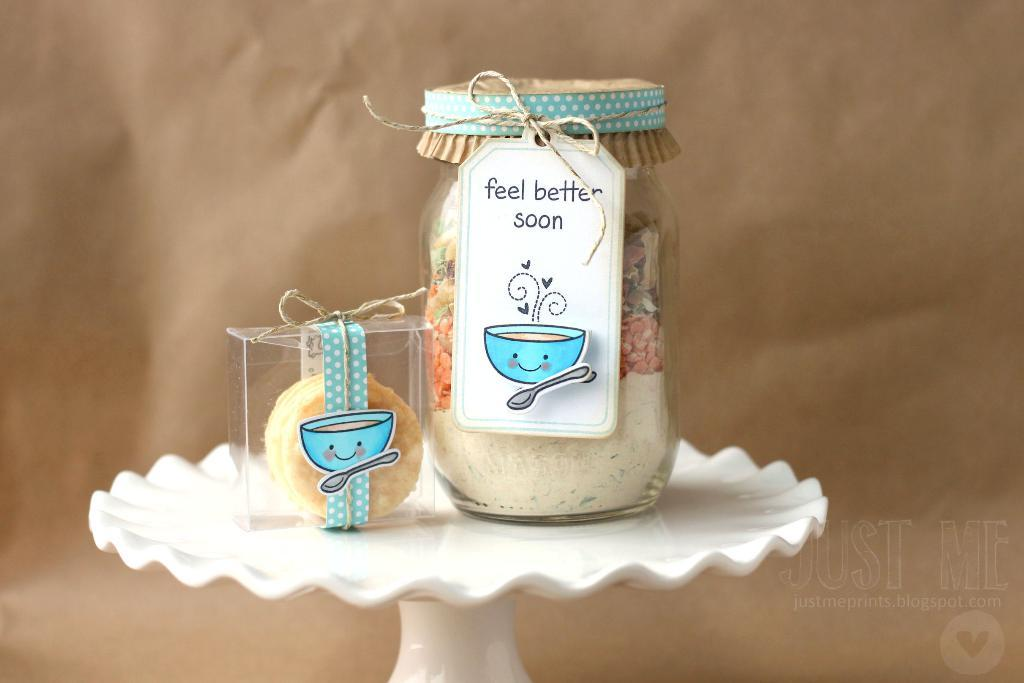Provide a one-sentence caption for the provided image. The tag on the jar indicates it's a gift for someone who is sick and conveys the gift giver hopes they feel better soon. 